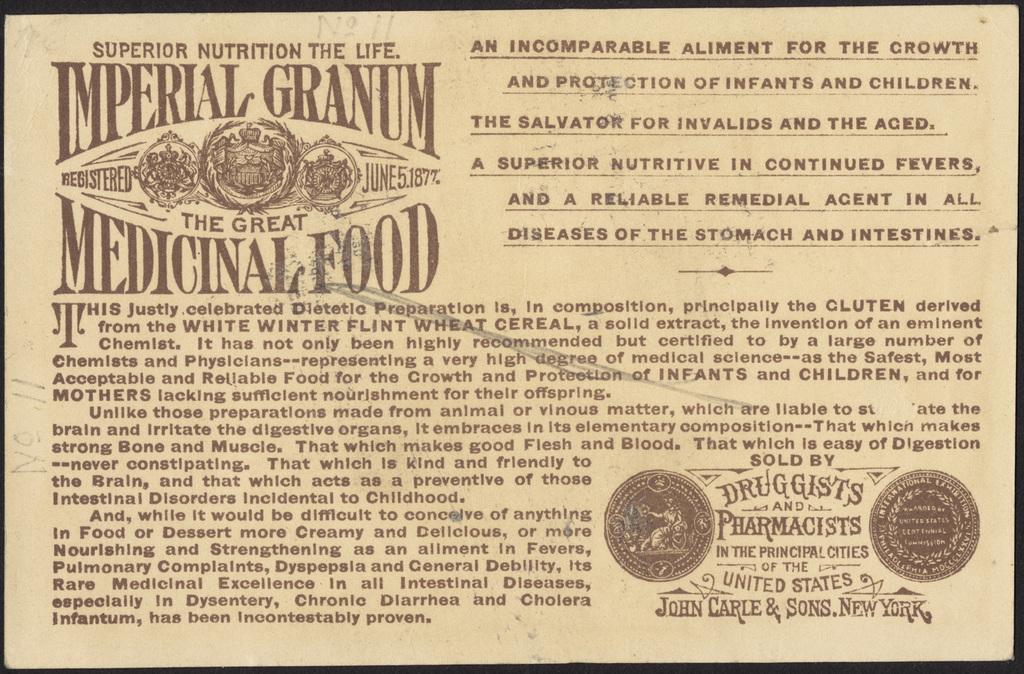What city is printed in the bottom right?
Ensure brevity in your answer.  New york. What type of cereal is this product derived from?
Provide a succinct answer. Imperial granum. 